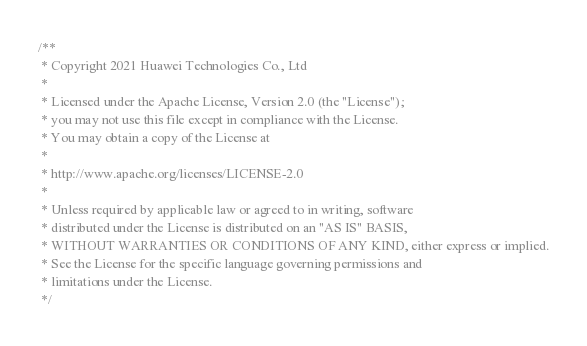Convert code to text. <code><loc_0><loc_0><loc_500><loc_500><_Cuda_>/**
 * Copyright 2021 Huawei Technologies Co., Ltd
 *
 * Licensed under the Apache License, Version 2.0 (the "License");
 * you may not use this file except in compliance with the License.
 * You may obtain a copy of the License at
 *
 * http://www.apache.org/licenses/LICENSE-2.0
 *
 * Unless required by applicable law or agreed to in writing, software
 * distributed under the License is distributed on an "AS IS" BASIS,
 * WITHOUT WARRANTIES OR CONDITIONS OF ANY KIND, either express or implied.
 * See the License for the specific language governing permissions and
 * limitations under the License.
 */</code> 